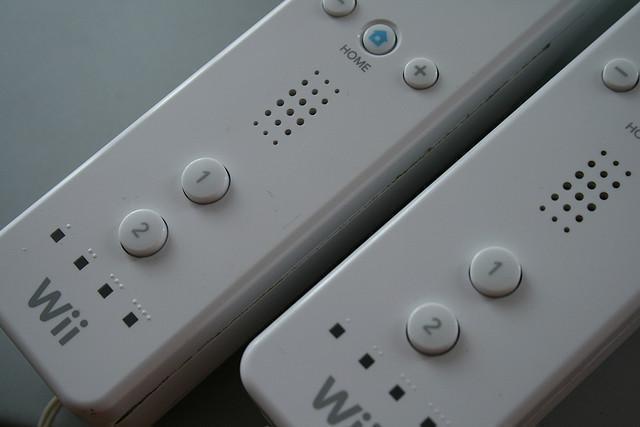How many WII remotes are here?
Give a very brief answer. 2. How many remotes are in the photo?
Give a very brief answer. 2. 